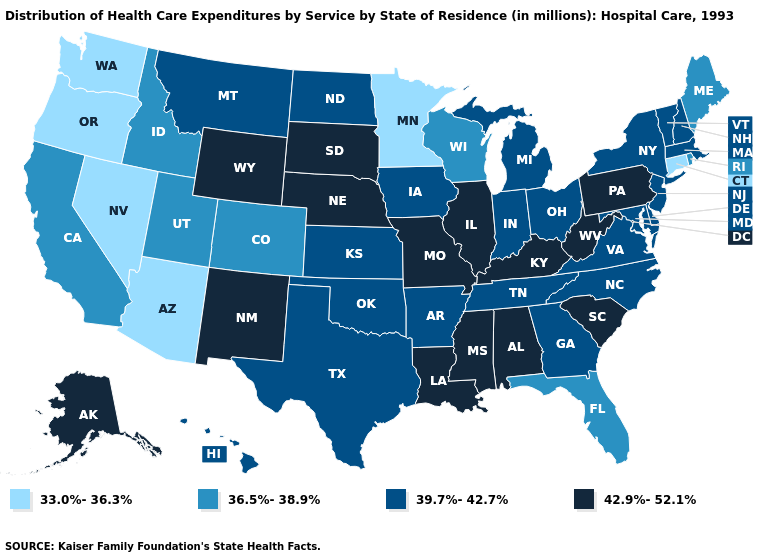What is the value of Kansas?
Quick response, please. 39.7%-42.7%. What is the value of Montana?
Answer briefly. 39.7%-42.7%. Name the states that have a value in the range 39.7%-42.7%?
Write a very short answer. Arkansas, Delaware, Georgia, Hawaii, Indiana, Iowa, Kansas, Maryland, Massachusetts, Michigan, Montana, New Hampshire, New Jersey, New York, North Carolina, North Dakota, Ohio, Oklahoma, Tennessee, Texas, Vermont, Virginia. Does Oregon have a lower value than New Mexico?
Give a very brief answer. Yes. Which states have the lowest value in the South?
Keep it brief. Florida. Does the first symbol in the legend represent the smallest category?
Short answer required. Yes. What is the lowest value in states that border Georgia?
Answer briefly. 36.5%-38.9%. Name the states that have a value in the range 33.0%-36.3%?
Answer briefly. Arizona, Connecticut, Minnesota, Nevada, Oregon, Washington. What is the value of Michigan?
Answer briefly. 39.7%-42.7%. Does Illinois have the highest value in the USA?
Answer briefly. Yes. What is the value of Arizona?
Answer briefly. 33.0%-36.3%. Is the legend a continuous bar?
Answer briefly. No. What is the lowest value in states that border Montana?
Give a very brief answer. 36.5%-38.9%. Does Michigan have a lower value than Oklahoma?
Write a very short answer. No. Name the states that have a value in the range 36.5%-38.9%?
Keep it brief. California, Colorado, Florida, Idaho, Maine, Rhode Island, Utah, Wisconsin. 